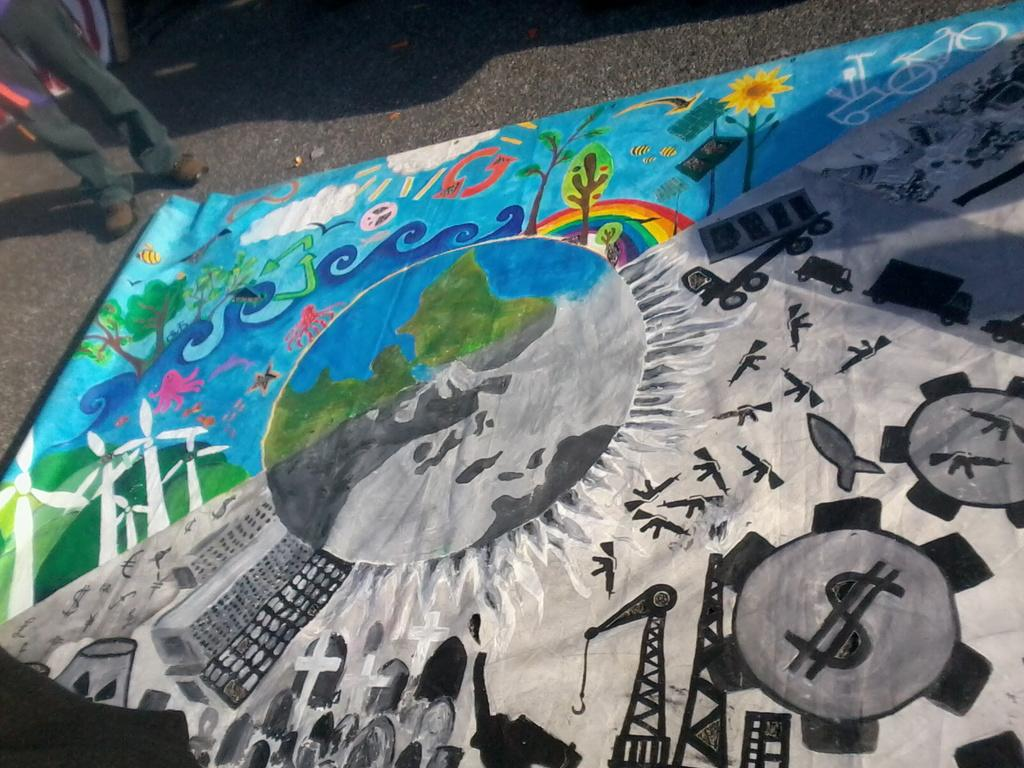What is the main subject of the image? There is a painting in the image. What else can be seen in the image besides the painting? There are objects and a person's legs visible on the road in the image. What is the rate at which the person is sneezing in the image? There is no indication of a person sneezing in the image; only their legs are visible on the road. 